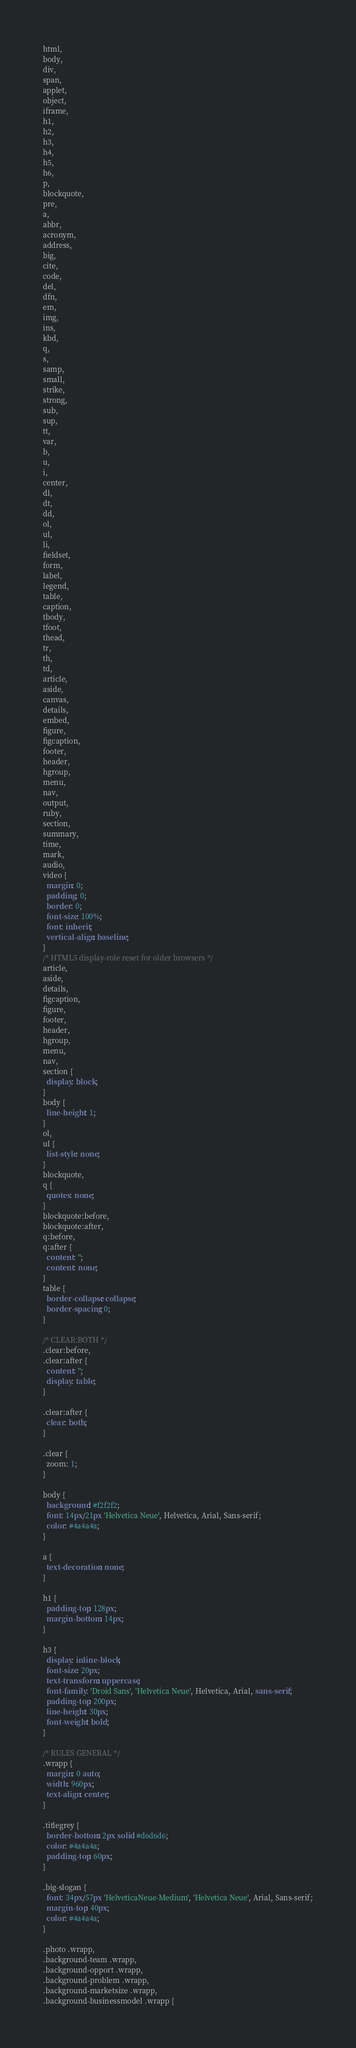Convert code to text. <code><loc_0><loc_0><loc_500><loc_500><_CSS_>html,
body,
div,
span,
applet,
object,
iframe,
h1,
h2,
h3,
h4,
h5,
h6,
p,
blockquote,
pre,
a,
abbr,
acronym,
address,
big,
cite,
code,
del,
dfn,
em,
img,
ins,
kbd,
q,
s,
samp,
small,
strike,
strong,
sub,
sup,
tt,
var,
b,
u,
i,
center,
dl,
dt,
dd,
ol,
ul,
li,
fieldset,
form,
label,
legend,
table,
caption,
tbody,
tfoot,
thead,
tr,
th,
td,
article,
aside,
canvas,
details,
embed,
figure,
figcaption,
footer,
header,
hgroup,
menu,
nav,
output,
ruby,
section,
summary,
time,
mark,
audio,
video {
  margin: 0;
  padding: 0;
  border: 0;
  font-size: 100%;
  font: inherit;
  vertical-align: baseline;
}
/* HTML5 display-role reset for older browsers */
article,
aside,
details,
figcaption,
figure,
footer,
header,
hgroup,
menu,
nav,
section {
  display: block;
}
body {
  line-height: 1;
}
ol,
ul {
  list-style: none;
}
blockquote,
q {
  quotes: none;
}
blockquote:before,
blockquote:after,
q:before,
q:after {
  content: '';
  content: none;
}
table {
  border-collapse: collapse;
  border-spacing: 0;
}

/* CLEAR:BOTH */
.clear:before,
.clear:after {
  content: '';
  display: table;
}

.clear:after {
  clear: both;
}

.clear {
  zoom: 1;
}

body {
  background: #f2f2f2;
  font: 14px/21px 'Helvetica Neue', Helvetica, Arial, Sans-serif;
  color: #4a4a4a;
}

a {
  text-decoration: none;
}

h1 {
  padding-top: 128px;
  margin-bottom: 14px;
}

h3 {
  display: inline-block;
  font-size: 20px;
  text-transform: uppercase;
  font-family: 'Droid Sans', 'Helvetica Neue', Helvetica, Arial, sans-serif;
  padding-top: 200px;
  line-height: 30px;
  font-weight: bold;
}

/* RULES GENERAL */
.wrapp {
  margin: 0 auto;
  width: 960px;
  text-align: center;
}

.titlegrey {
  border-bottom: 2px solid #d6d6d6;
  color: #4a4a4a;
  padding-top: 60px;
}

.big-slogan {
  font: 34px/57px 'HelveticaNeue-Medium', 'Helvetica Neue', Arial, Sans-serif;
  margin-top: 40px;
  color: #4a4a4a;
}

.photo .wrapp,
.background-team .wrapp,
.background-opport .wrapp,
.background-problem .wrapp,
.background-marketsize .wrapp,
.background-businessmodel .wrapp {</code> 